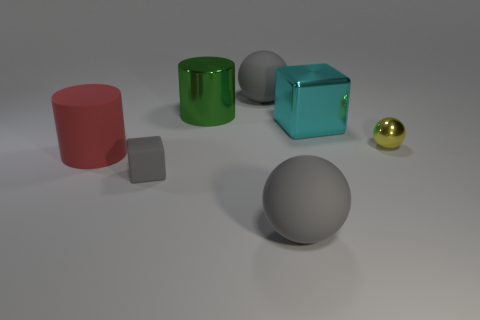What number of other things are there of the same color as the matte block?
Provide a short and direct response. 2. Is the number of small rubber blocks that are left of the red rubber cylinder less than the number of objects in front of the big cyan cube?
Keep it short and to the point. Yes. How many things are either large rubber things that are in front of the metal sphere or cubes?
Provide a succinct answer. 4. There is a green cylinder; does it have the same size as the block that is to the left of the large green metallic cylinder?
Offer a very short reply. No. There is a gray matte thing that is the same shape as the cyan object; what is its size?
Give a very brief answer. Small. How many large matte things are to the right of the large gray rubber sphere that is in front of the large cylinder behind the yellow sphere?
Give a very brief answer. 0. How many blocks are either red objects or gray rubber things?
Give a very brief answer. 1. What color is the tiny object to the right of the matte ball that is behind the large ball that is in front of the large green shiny object?
Offer a very short reply. Yellow. How many other objects are there of the same size as the red matte cylinder?
Make the answer very short. 4. There is a tiny rubber thing that is the same shape as the large cyan object; what is its color?
Make the answer very short. Gray. 